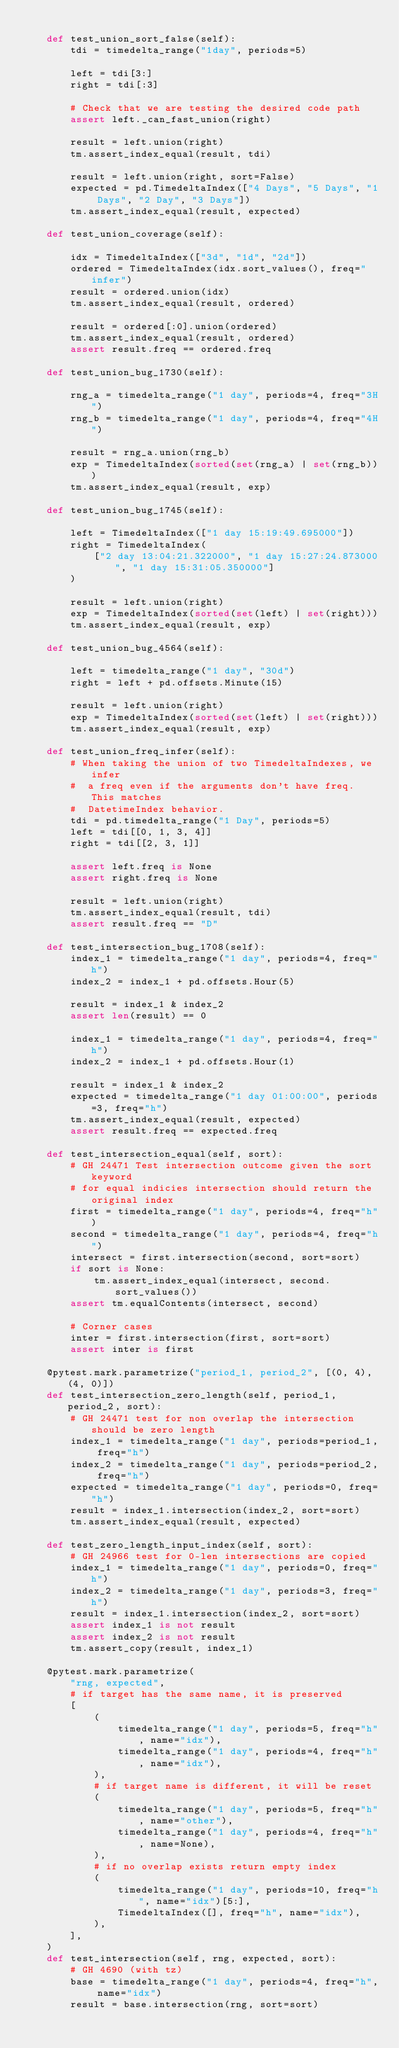Convert code to text. <code><loc_0><loc_0><loc_500><loc_500><_Python_>
    def test_union_sort_false(self):
        tdi = timedelta_range("1day", periods=5)

        left = tdi[3:]
        right = tdi[:3]

        # Check that we are testing the desired code path
        assert left._can_fast_union(right)

        result = left.union(right)
        tm.assert_index_equal(result, tdi)

        result = left.union(right, sort=False)
        expected = pd.TimedeltaIndex(["4 Days", "5 Days", "1 Days", "2 Day", "3 Days"])
        tm.assert_index_equal(result, expected)

    def test_union_coverage(self):

        idx = TimedeltaIndex(["3d", "1d", "2d"])
        ordered = TimedeltaIndex(idx.sort_values(), freq="infer")
        result = ordered.union(idx)
        tm.assert_index_equal(result, ordered)

        result = ordered[:0].union(ordered)
        tm.assert_index_equal(result, ordered)
        assert result.freq == ordered.freq

    def test_union_bug_1730(self):

        rng_a = timedelta_range("1 day", periods=4, freq="3H")
        rng_b = timedelta_range("1 day", periods=4, freq="4H")

        result = rng_a.union(rng_b)
        exp = TimedeltaIndex(sorted(set(rng_a) | set(rng_b)))
        tm.assert_index_equal(result, exp)

    def test_union_bug_1745(self):

        left = TimedeltaIndex(["1 day 15:19:49.695000"])
        right = TimedeltaIndex(
            ["2 day 13:04:21.322000", "1 day 15:27:24.873000", "1 day 15:31:05.350000"]
        )

        result = left.union(right)
        exp = TimedeltaIndex(sorted(set(left) | set(right)))
        tm.assert_index_equal(result, exp)

    def test_union_bug_4564(self):

        left = timedelta_range("1 day", "30d")
        right = left + pd.offsets.Minute(15)

        result = left.union(right)
        exp = TimedeltaIndex(sorted(set(left) | set(right)))
        tm.assert_index_equal(result, exp)

    def test_union_freq_infer(self):
        # When taking the union of two TimedeltaIndexes, we infer
        #  a freq even if the arguments don't have freq.  This matches
        #  DatetimeIndex behavior.
        tdi = pd.timedelta_range("1 Day", periods=5)
        left = tdi[[0, 1, 3, 4]]
        right = tdi[[2, 3, 1]]

        assert left.freq is None
        assert right.freq is None

        result = left.union(right)
        tm.assert_index_equal(result, tdi)
        assert result.freq == "D"

    def test_intersection_bug_1708(self):
        index_1 = timedelta_range("1 day", periods=4, freq="h")
        index_2 = index_1 + pd.offsets.Hour(5)

        result = index_1 & index_2
        assert len(result) == 0

        index_1 = timedelta_range("1 day", periods=4, freq="h")
        index_2 = index_1 + pd.offsets.Hour(1)

        result = index_1 & index_2
        expected = timedelta_range("1 day 01:00:00", periods=3, freq="h")
        tm.assert_index_equal(result, expected)
        assert result.freq == expected.freq

    def test_intersection_equal(self, sort):
        # GH 24471 Test intersection outcome given the sort keyword
        # for equal indicies intersection should return the original index
        first = timedelta_range("1 day", periods=4, freq="h")
        second = timedelta_range("1 day", periods=4, freq="h")
        intersect = first.intersection(second, sort=sort)
        if sort is None:
            tm.assert_index_equal(intersect, second.sort_values())
        assert tm.equalContents(intersect, second)

        # Corner cases
        inter = first.intersection(first, sort=sort)
        assert inter is first

    @pytest.mark.parametrize("period_1, period_2", [(0, 4), (4, 0)])
    def test_intersection_zero_length(self, period_1, period_2, sort):
        # GH 24471 test for non overlap the intersection should be zero length
        index_1 = timedelta_range("1 day", periods=period_1, freq="h")
        index_2 = timedelta_range("1 day", periods=period_2, freq="h")
        expected = timedelta_range("1 day", periods=0, freq="h")
        result = index_1.intersection(index_2, sort=sort)
        tm.assert_index_equal(result, expected)

    def test_zero_length_input_index(self, sort):
        # GH 24966 test for 0-len intersections are copied
        index_1 = timedelta_range("1 day", periods=0, freq="h")
        index_2 = timedelta_range("1 day", periods=3, freq="h")
        result = index_1.intersection(index_2, sort=sort)
        assert index_1 is not result
        assert index_2 is not result
        tm.assert_copy(result, index_1)

    @pytest.mark.parametrize(
        "rng, expected",
        # if target has the same name, it is preserved
        [
            (
                timedelta_range("1 day", periods=5, freq="h", name="idx"),
                timedelta_range("1 day", periods=4, freq="h", name="idx"),
            ),
            # if target name is different, it will be reset
            (
                timedelta_range("1 day", periods=5, freq="h", name="other"),
                timedelta_range("1 day", periods=4, freq="h", name=None),
            ),
            # if no overlap exists return empty index
            (
                timedelta_range("1 day", periods=10, freq="h", name="idx")[5:],
                TimedeltaIndex([], freq="h", name="idx"),
            ),
        ],
    )
    def test_intersection(self, rng, expected, sort):
        # GH 4690 (with tz)
        base = timedelta_range("1 day", periods=4, freq="h", name="idx")
        result = base.intersection(rng, sort=sort)</code> 